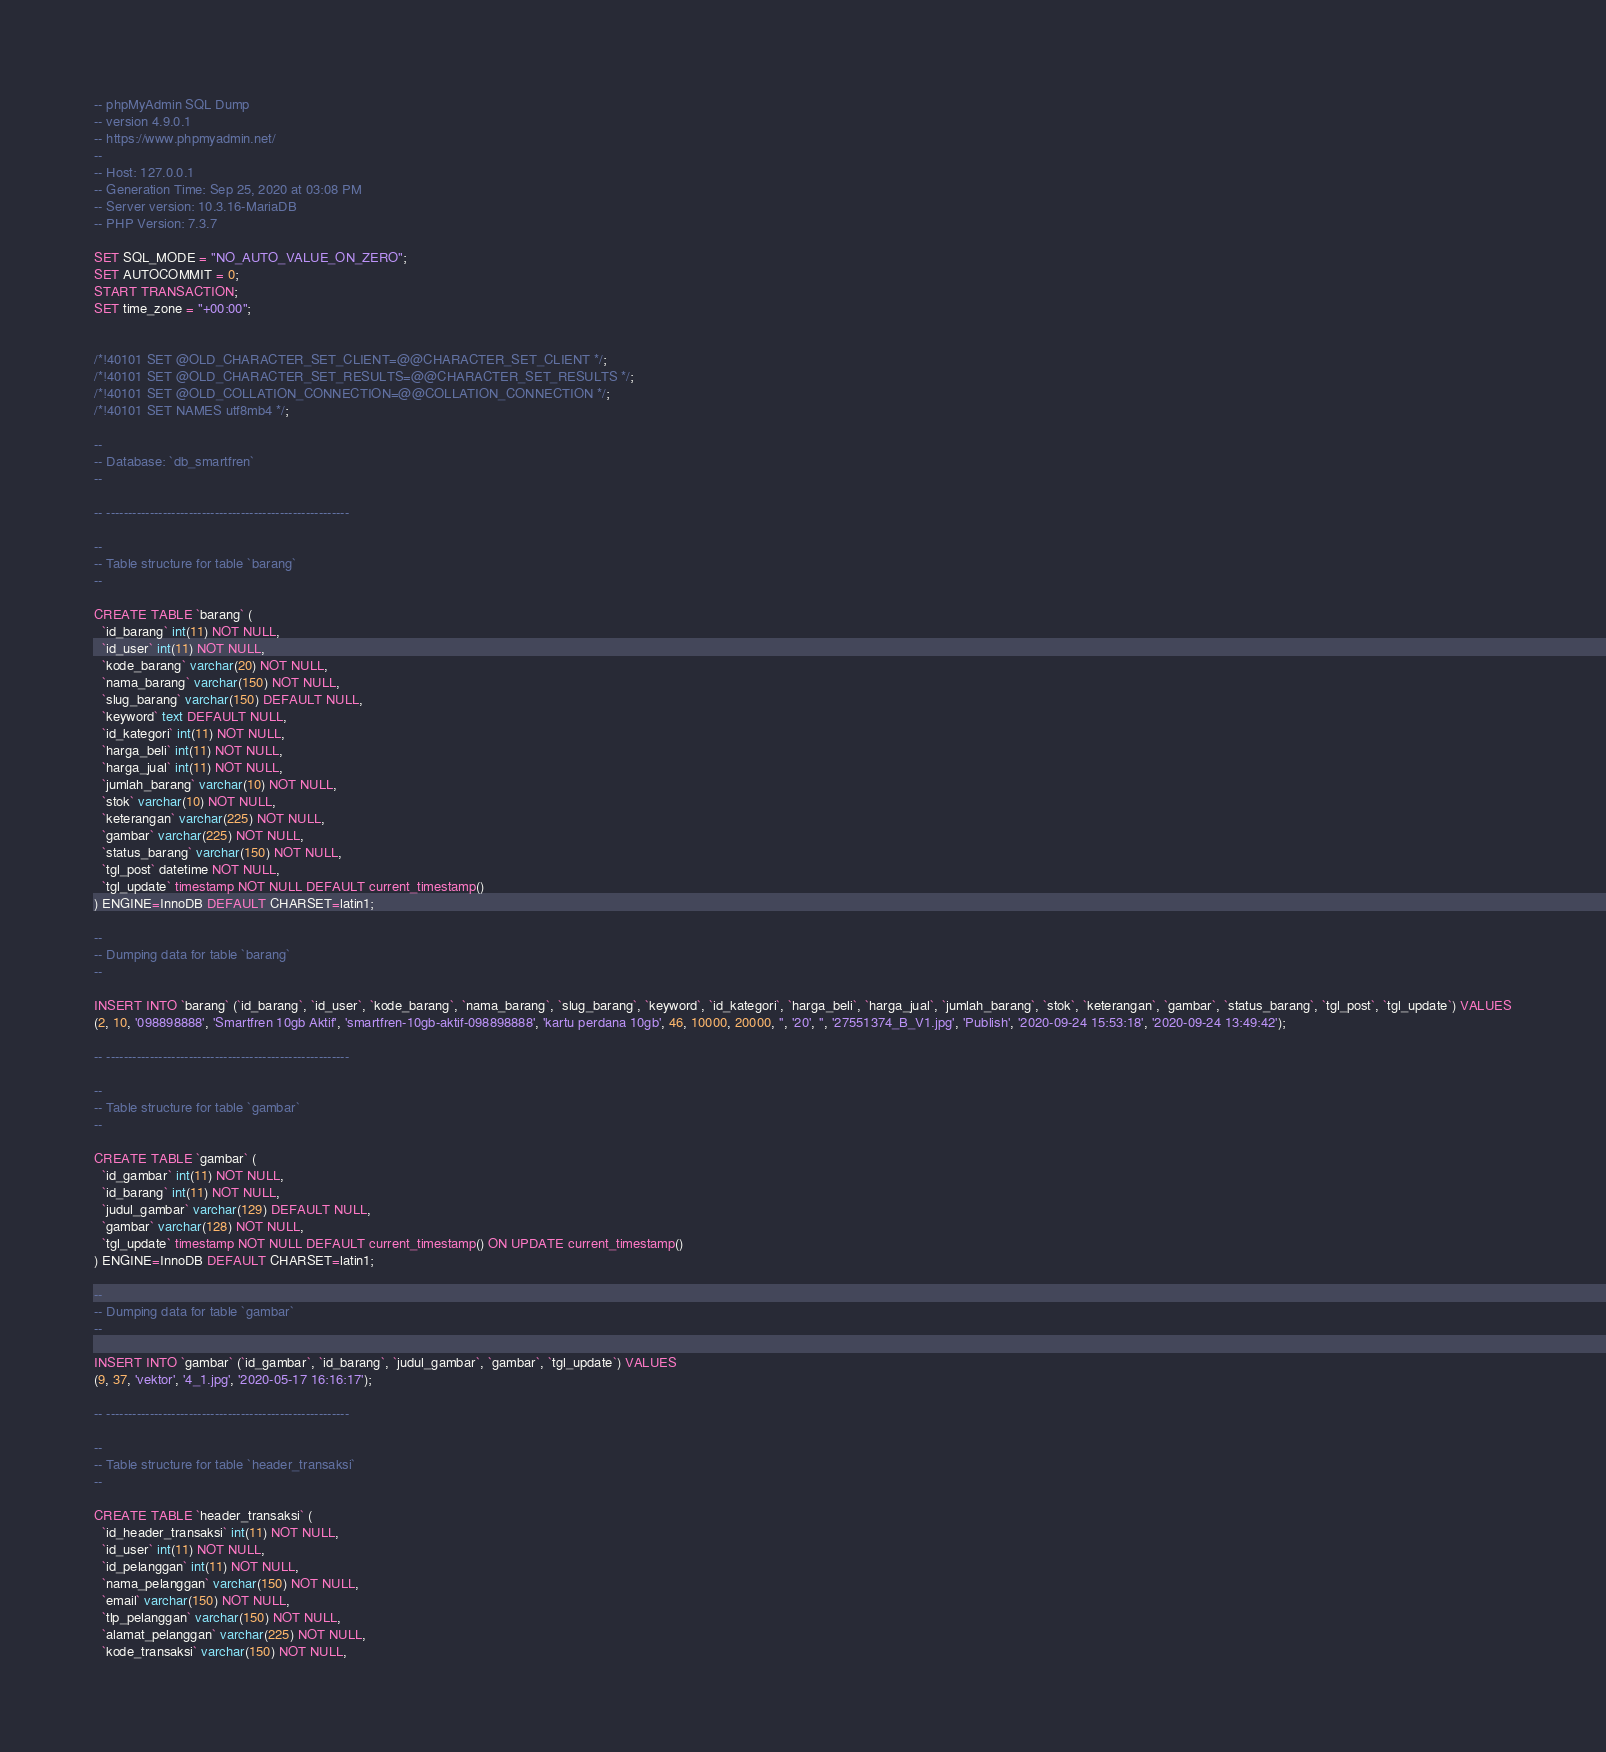<code> <loc_0><loc_0><loc_500><loc_500><_SQL_>-- phpMyAdmin SQL Dump
-- version 4.9.0.1
-- https://www.phpmyadmin.net/
--
-- Host: 127.0.0.1
-- Generation Time: Sep 25, 2020 at 03:08 PM
-- Server version: 10.3.16-MariaDB
-- PHP Version: 7.3.7

SET SQL_MODE = "NO_AUTO_VALUE_ON_ZERO";
SET AUTOCOMMIT = 0;
START TRANSACTION;
SET time_zone = "+00:00";


/*!40101 SET @OLD_CHARACTER_SET_CLIENT=@@CHARACTER_SET_CLIENT */;
/*!40101 SET @OLD_CHARACTER_SET_RESULTS=@@CHARACTER_SET_RESULTS */;
/*!40101 SET @OLD_COLLATION_CONNECTION=@@COLLATION_CONNECTION */;
/*!40101 SET NAMES utf8mb4 */;

--
-- Database: `db_smartfren`
--

-- --------------------------------------------------------

--
-- Table structure for table `barang`
--

CREATE TABLE `barang` (
  `id_barang` int(11) NOT NULL,
  `id_user` int(11) NOT NULL,
  `kode_barang` varchar(20) NOT NULL,
  `nama_barang` varchar(150) NOT NULL,
  `slug_barang` varchar(150) DEFAULT NULL,
  `keyword` text DEFAULT NULL,
  `id_kategori` int(11) NOT NULL,
  `harga_beli` int(11) NOT NULL,
  `harga_jual` int(11) NOT NULL,
  `jumlah_barang` varchar(10) NOT NULL,
  `stok` varchar(10) NOT NULL,
  `keterangan` varchar(225) NOT NULL,
  `gambar` varchar(225) NOT NULL,
  `status_barang` varchar(150) NOT NULL,
  `tgl_post` datetime NOT NULL,
  `tgl_update` timestamp NOT NULL DEFAULT current_timestamp()
) ENGINE=InnoDB DEFAULT CHARSET=latin1;

--
-- Dumping data for table `barang`
--

INSERT INTO `barang` (`id_barang`, `id_user`, `kode_barang`, `nama_barang`, `slug_barang`, `keyword`, `id_kategori`, `harga_beli`, `harga_jual`, `jumlah_barang`, `stok`, `keterangan`, `gambar`, `status_barang`, `tgl_post`, `tgl_update`) VALUES
(2, 10, '098898888', 'Smartfren 10gb Aktif', 'smartfren-10gb-aktif-098898888', 'kartu perdana 10gb', 46, 10000, 20000, '', '20', '', '27551374_B_V1.jpg', 'Publish', '2020-09-24 15:53:18', '2020-09-24 13:49:42');

-- --------------------------------------------------------

--
-- Table structure for table `gambar`
--

CREATE TABLE `gambar` (
  `id_gambar` int(11) NOT NULL,
  `id_barang` int(11) NOT NULL,
  `judul_gambar` varchar(129) DEFAULT NULL,
  `gambar` varchar(128) NOT NULL,
  `tgl_update` timestamp NOT NULL DEFAULT current_timestamp() ON UPDATE current_timestamp()
) ENGINE=InnoDB DEFAULT CHARSET=latin1;

--
-- Dumping data for table `gambar`
--

INSERT INTO `gambar` (`id_gambar`, `id_barang`, `judul_gambar`, `gambar`, `tgl_update`) VALUES
(9, 37, 'vektor', '4_1.jpg', '2020-05-17 16:16:17');

-- --------------------------------------------------------

--
-- Table structure for table `header_transaksi`
--

CREATE TABLE `header_transaksi` (
  `id_header_transaksi` int(11) NOT NULL,
  `id_user` int(11) NOT NULL,
  `id_pelanggan` int(11) NOT NULL,
  `nama_pelanggan` varchar(150) NOT NULL,
  `email` varchar(150) NOT NULL,
  `tlp_pelanggan` varchar(150) NOT NULL,
  `alamat_pelanggan` varchar(225) NOT NULL,
  `kode_transaksi` varchar(150) NOT NULL,</code> 